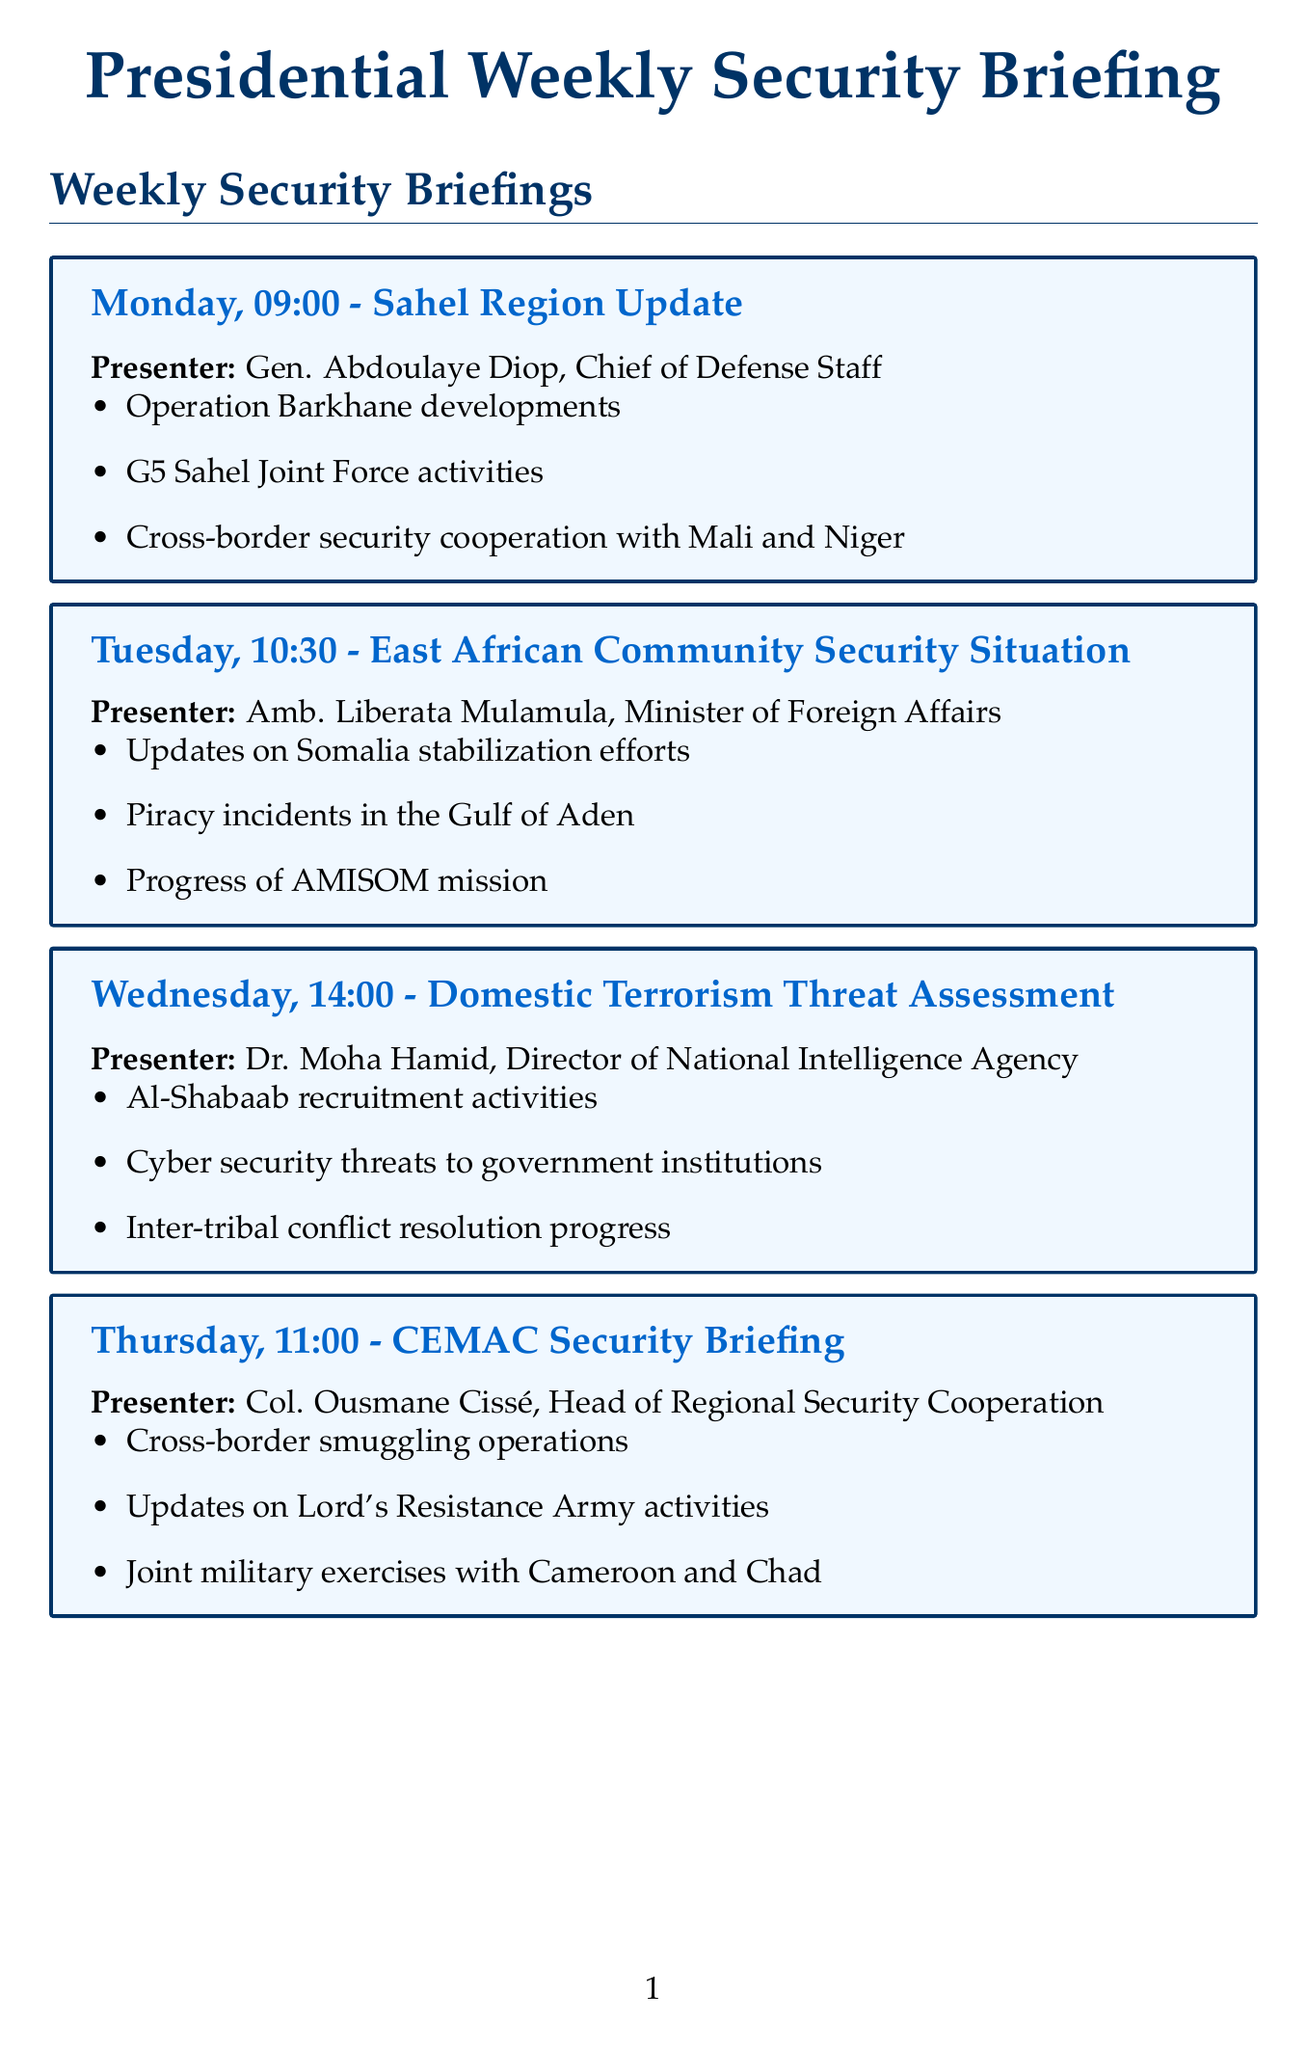What day is the East African Community Security Situation briefing scheduled? The East African Community Security Situation briefing is scheduled for Tuesday.
Answer: Tuesday Who presents the update on the Sahel Region? The presenter of the Sahel Region Update is Gen. Abdoulaye Diop, Chief of Defense Staff.
Answer: Gen. Abdoulaye Diop, Chief of Defense Staff What time is the briefing on Domestic Terrorism Threat Assessment? The briefing on Domestic Terrorism Threat Assessment takes place at 14:00 on Wednesday.
Answer: 14:00 What is one of the key actions for a terrorist attack on government facilities? One of the key actions is to activate the National Emergency Operations Center.
Answer: Activate National Emergency Operations Center Which day features the United Nations Peacekeeping Operations Review meeting? The United Nations Peacekeeping Operations Review meeting is scheduled for Thursday.
Answer: Thursday What are the attendees for the Bilateral Security Cooperation with France meeting? The attendees include the French Ambassador, Minister of Defense, and Chief of Intelligence Services.
Answer: French Ambassador, Minister of Defense, Chief of Intelligence Services How many key points are listed in the Central African Economic and Monetary Community Security Briefing? There are three key points listed for the Central African Economic and Monetary Community Security Briefing.
Answer: Three Who is responsible for the response during a natural disaster affecting multiple regions? The National Disaster Management Agency is responsible for the response during a natural disaster.
Answer: National Disaster Management Agency 